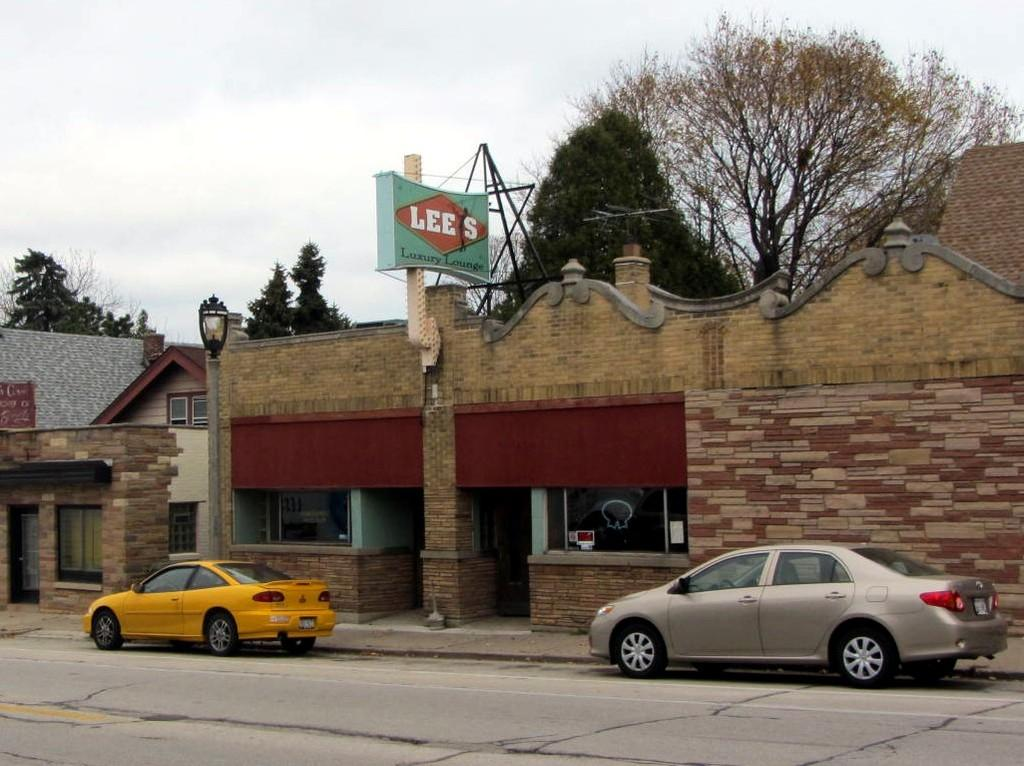What type of vehicles can be seen on the road in the image? There are cars on the road in the image. What structure is present in the image? There is a wall and a house in the image. What object can be seen in the image that might be used for displaying information or advertisements? There is a board in the image. What type of illumination is visible in the image? There is a light in the image. What type of natural scenery can be seen in the background of the image? There are trees in the background of the image. What part of the natural environment is visible in the background of the image? The sky is visible in the background of the image. What type of beef is being served in the image? There is no beef present in the image. How many pies can be seen on the board in the image? There are no pies visible in the image. 